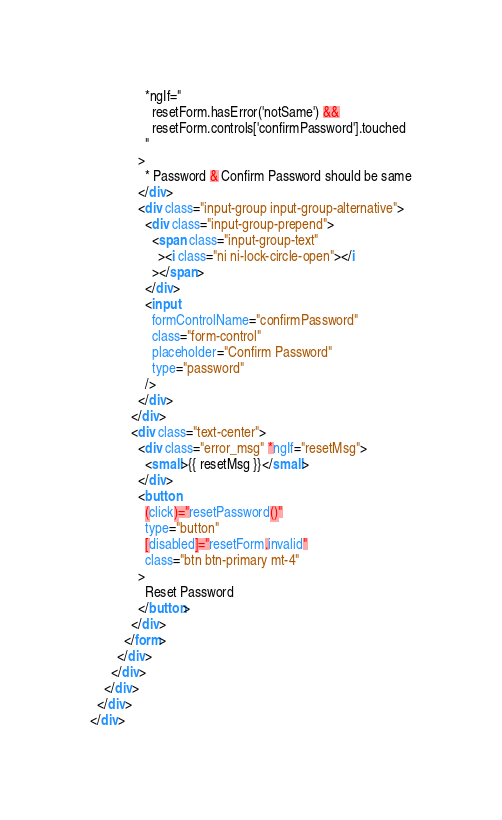<code> <loc_0><loc_0><loc_500><loc_500><_HTML_>                *ngIf="
                  resetForm.hasError('notSame') &&
                  resetForm.controls['confirmPassword'].touched
                "
              >
                * Password & Confirm Password should be same
              </div>
              <div class="input-group input-group-alternative">
                <div class="input-group-prepend">
                  <span class="input-group-text"
                    ><i class="ni ni-lock-circle-open"></i
                  ></span>
                </div>
                <input
                  formControlName="confirmPassword"
                  class="form-control"
                  placeholder="Confirm Password"
                  type="password"
                />
              </div>
            </div>
            <div class="text-center">
              <div class="error_msg" *ngIf="resetMsg">
                <small>{{ resetMsg }}</small>
              </div>
              <button
                (click)="resetPassword()"
                type="button"
                [disabled]="resetForm.invalid"
                class="btn btn-primary mt-4"
              >
                Reset Password
              </button>
            </div>
          </form>
        </div>
      </div>
    </div>
  </div>
</div>
</code> 